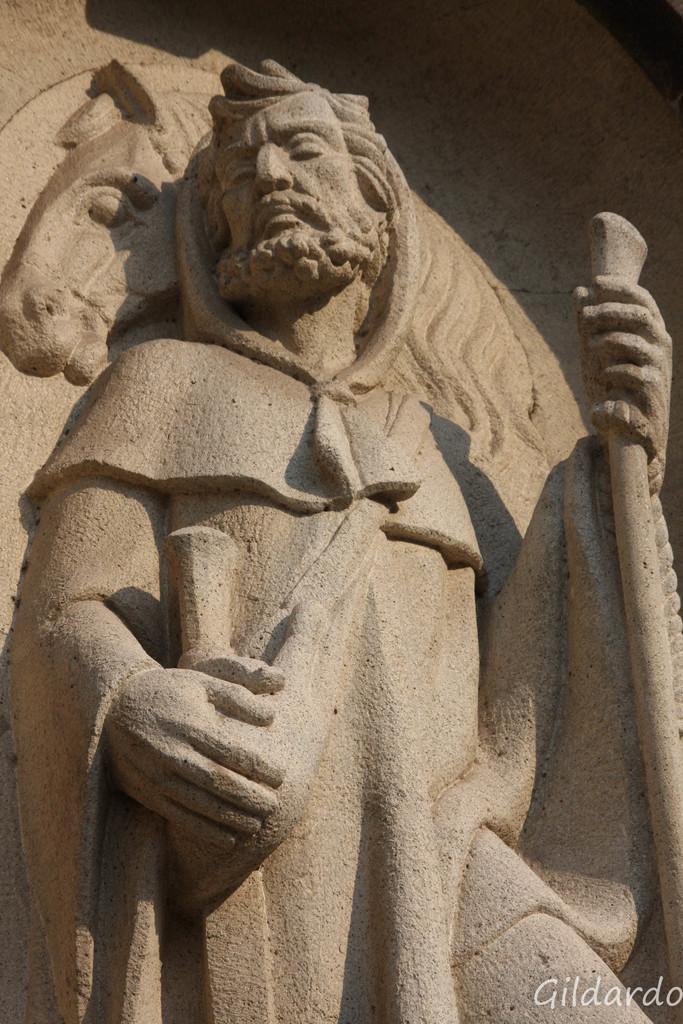How would you summarize this image in a sentence or two? In this image, we can see a sculpture. There is a text in the bottom right of the image. 